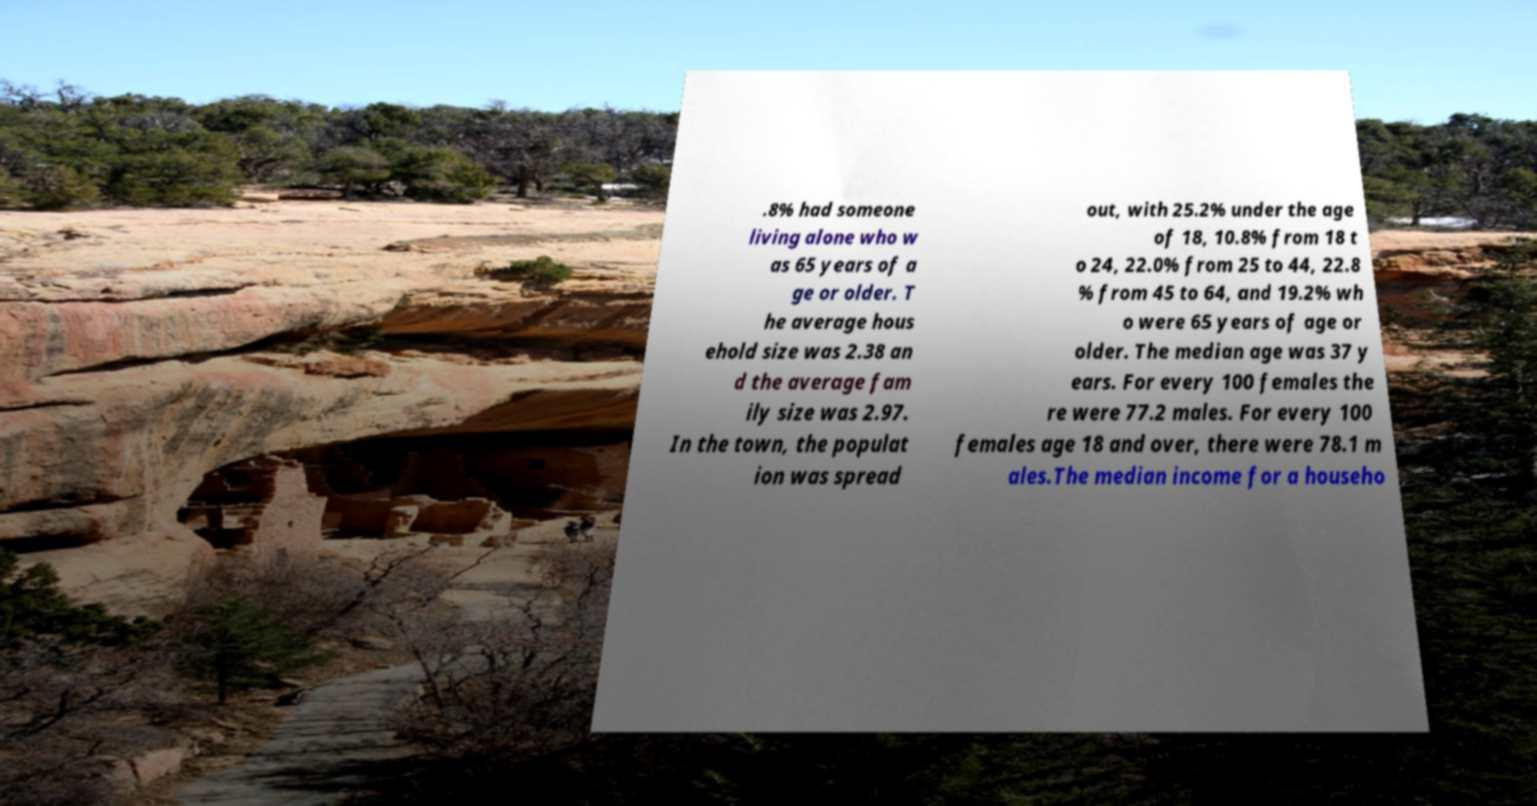What messages or text are displayed in this image? I need them in a readable, typed format. .8% had someone living alone who w as 65 years of a ge or older. T he average hous ehold size was 2.38 an d the average fam ily size was 2.97. In the town, the populat ion was spread out, with 25.2% under the age of 18, 10.8% from 18 t o 24, 22.0% from 25 to 44, 22.8 % from 45 to 64, and 19.2% wh o were 65 years of age or older. The median age was 37 y ears. For every 100 females the re were 77.2 males. For every 100 females age 18 and over, there were 78.1 m ales.The median income for a househo 